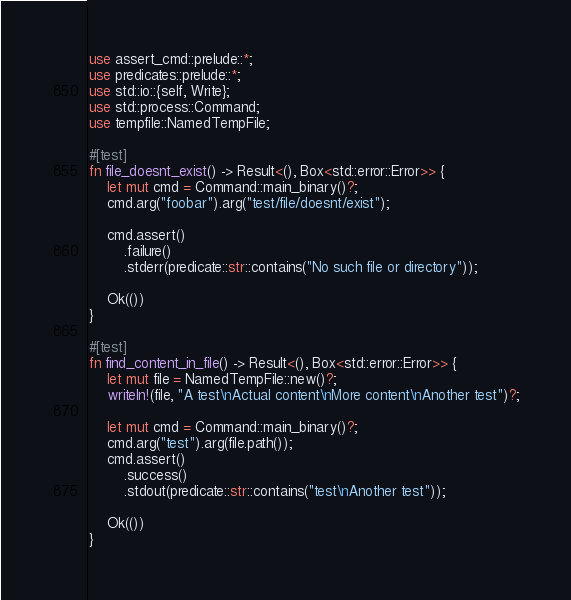Convert code to text. <code><loc_0><loc_0><loc_500><loc_500><_Rust_>use assert_cmd::prelude::*;
use predicates::prelude::*;
use std::io::{self, Write};
use std::process::Command;
use tempfile::NamedTempFile;

#[test]
fn file_doesnt_exist() -> Result<(), Box<std::error::Error>> {
    let mut cmd = Command::main_binary()?;
    cmd.arg("foobar").arg("test/file/doesnt/exist");

    cmd.assert()
        .failure()
        .stderr(predicate::str::contains("No such file or directory"));

    Ok(())
}

#[test]
fn find_content_in_file() -> Result<(), Box<std::error::Error>> {
    let mut file = NamedTempFile::new()?;
    writeln!(file, "A test\nActual content\nMore content\nAnother test")?;

    let mut cmd = Command::main_binary()?;
    cmd.arg("test").arg(file.path());
    cmd.assert()
        .success()
        .stdout(predicate::str::contains("test\nAnother test"));

    Ok(())
}
</code> 